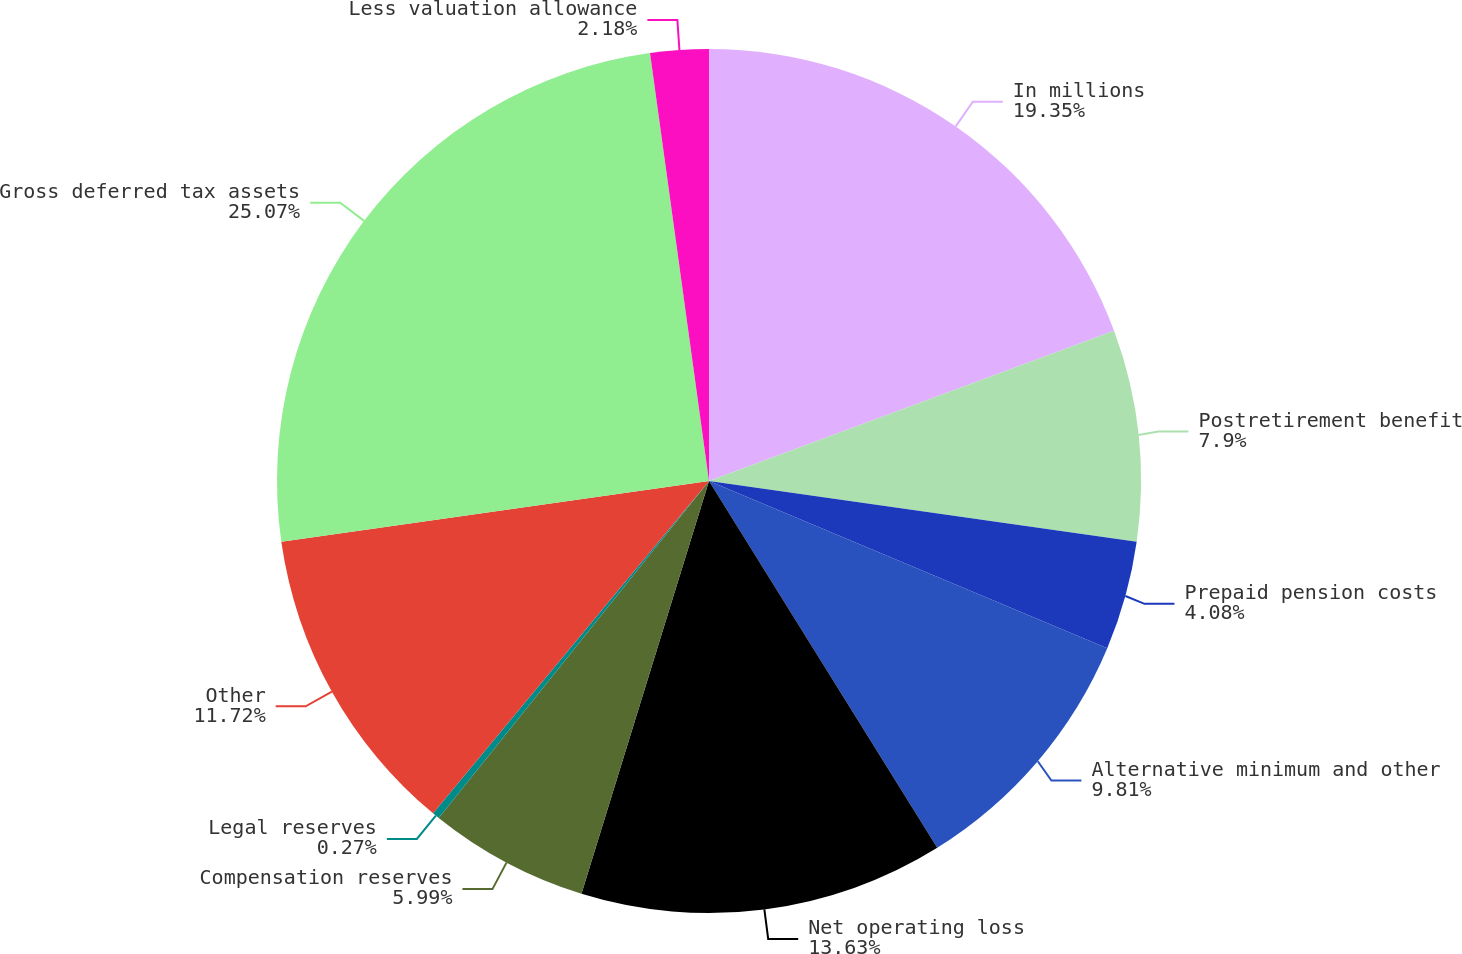Convert chart to OTSL. <chart><loc_0><loc_0><loc_500><loc_500><pie_chart><fcel>In millions<fcel>Postretirement benefit<fcel>Prepaid pension costs<fcel>Alternative minimum and other<fcel>Net operating loss<fcel>Compensation reserves<fcel>Legal reserves<fcel>Other<fcel>Gross deferred tax assets<fcel>Less valuation allowance<nl><fcel>19.35%<fcel>7.9%<fcel>4.08%<fcel>9.81%<fcel>13.63%<fcel>5.99%<fcel>0.27%<fcel>11.72%<fcel>25.07%<fcel>2.18%<nl></chart> 